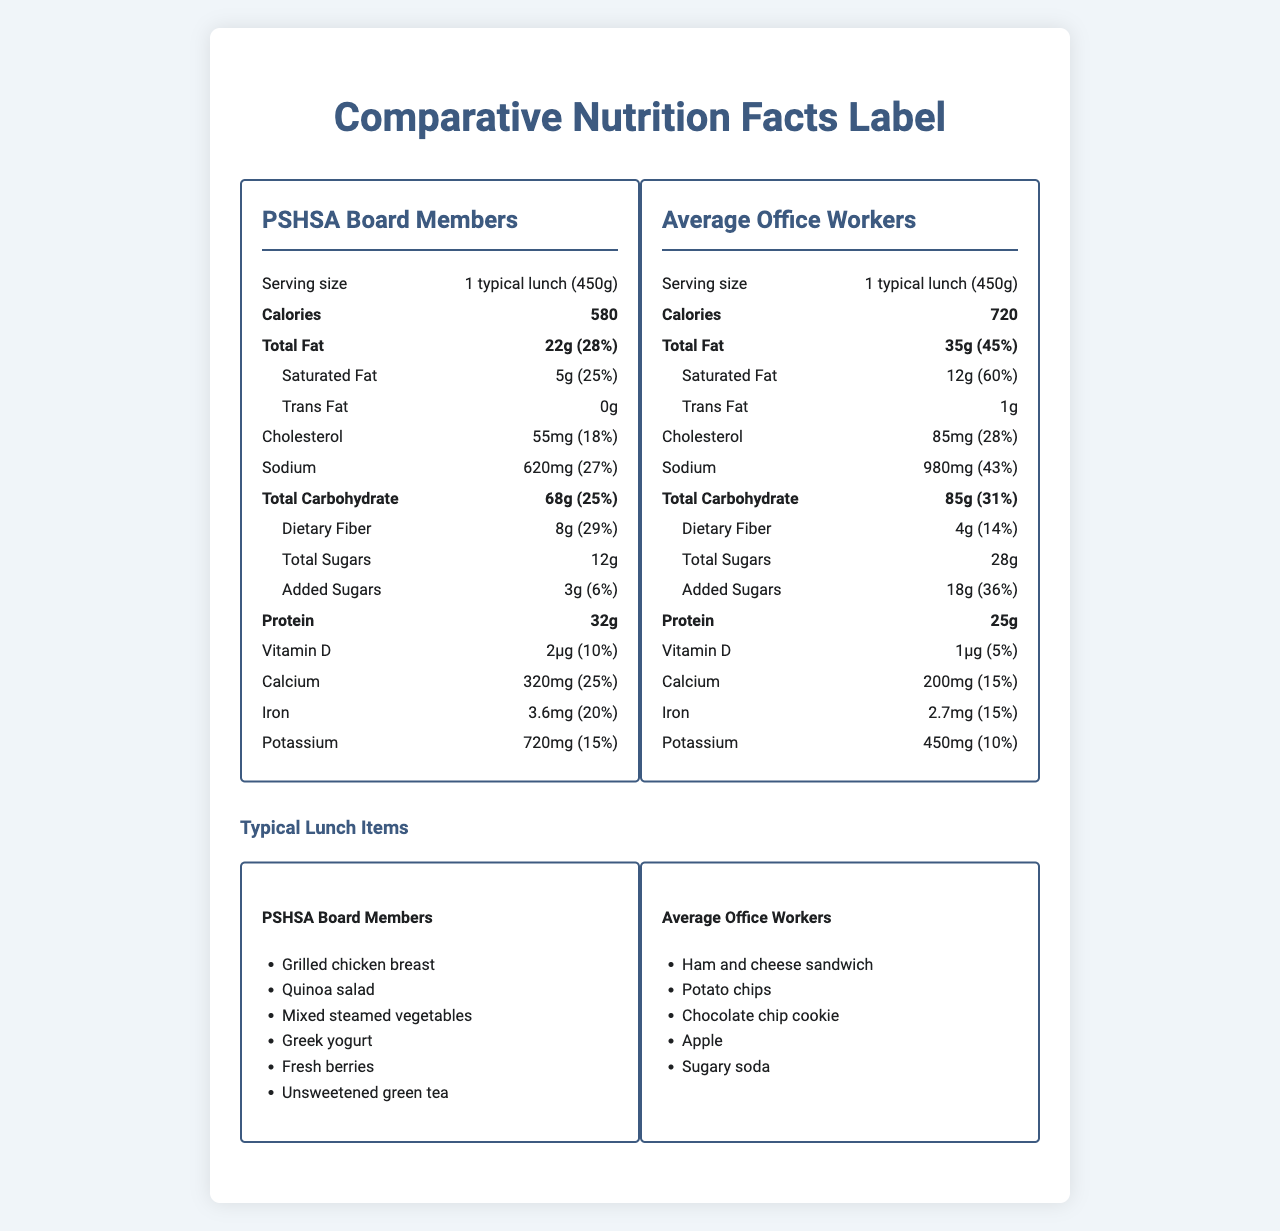which meal has fewer calories? The PSHSA Board Members' lunch has 580 calories, whereas the average office workers' lunch has 720 calories.
Answer: PSHSA Board Members' lunch how many grams of dietary fiber are in the PSHSA Board Members' lunch? The PSHSA Board Members' lunch contains 8 grams of dietary fiber.
Answer: 8 grams how much protein does the average office workers' lunch provide? The average office workers' lunch provides 25 grams of protein.
Answer: 25 grams what is the serving size for both lunch choices? The serving size for both lunch choices is specified as 1 typical lunch (450g).
Answer: 1 typical lunch (450g) what is the difference in the amount of added sugars between the two lunches? The PSHSA Board Members' lunch has 3 grams of added sugars, while the average office workers' lunch has 18 grams of added sugars.
Answer: 15 grams which lunch has a higher percentage of daily value for saturated fat? 
A. PSHSA Board Members' lunch 
B. Average office workers' lunch 
C. Both have the same percentage The average office workers' lunch has 60% of the daily value for saturated fat, whereas the PSHSA Board Members' lunch has 25%.
Answer: B which of the following is a typical lunch item for PSHSA Board Members but not for average office workers? 
I. Grilled chicken breast 
II. Potato chips 
III. Sugary soda 
IV. Greek yogurt Grilled chicken breast and Greek yogurt are listed as typical lunch items for PSHSA Board Members but not for average office workers.
Answer: I and IV do PSHSA Board Members consume more total carbohydrates than average office workers? The PSHSA Board Members' lunch contains 68 grams of total carbohydrates, whereas the average office workers' lunch contains 85 grams.
Answer: No describe the main idea of the document. The explanation includes various nutritional components and the types of foods consumed by each group to illustrate dietary differences.
Answer: The document compares the nutrition facts and typical lunch items of PSHSA Board Members and average office workers. It provides detailed information on calories, fats, cholesterol, sodium, carbohydrates, protein, vitamins, minerals, and typical foods for each group. what is the cholesterol content in milligrams for the PSHSA Board Members' lunch? The PSHSA Board Members' lunch contains 55 milligrams of cholesterol.
Answer: 55 milligrams is there information about the Vitamin C content in the lunches? The document does not provide information on the Vitamin C content for either the PSHSA Board Members' lunch or the average office workers' lunch.
Answer: I don't know 